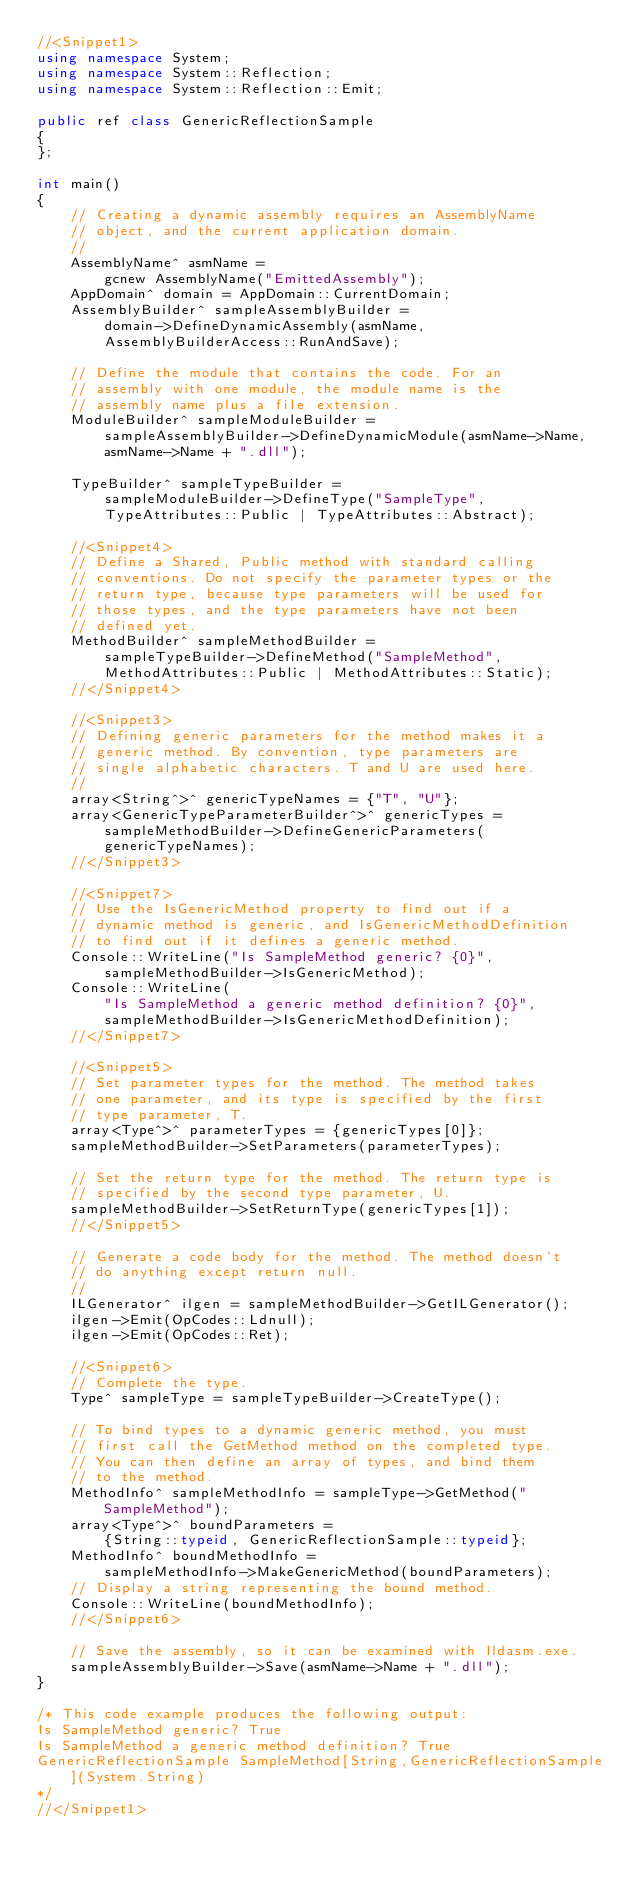<code> <loc_0><loc_0><loc_500><loc_500><_C++_>//<Snippet1>
using namespace System;
using namespace System::Reflection;
using namespace System::Reflection::Emit;

public ref class GenericReflectionSample
{
};

int main()
{
    // Creating a dynamic assembly requires an AssemblyName
    // object, and the current application domain.
    //
    AssemblyName^ asmName =
        gcnew AssemblyName("EmittedAssembly");
    AppDomain^ domain = AppDomain::CurrentDomain;
    AssemblyBuilder^ sampleAssemblyBuilder =
        domain->DefineDynamicAssembly(asmName,
        AssemblyBuilderAccess::RunAndSave);

    // Define the module that contains the code. For an
    // assembly with one module, the module name is the
    // assembly name plus a file extension.
    ModuleBuilder^ sampleModuleBuilder =
        sampleAssemblyBuilder->DefineDynamicModule(asmName->Name,
        asmName->Name + ".dll");

    TypeBuilder^ sampleTypeBuilder =
        sampleModuleBuilder->DefineType("SampleType",
        TypeAttributes::Public | TypeAttributes::Abstract);

    //<Snippet4>
    // Define a Shared, Public method with standard calling
    // conventions. Do not specify the parameter types or the
    // return type, because type parameters will be used for
    // those types, and the type parameters have not been
    // defined yet.
    MethodBuilder^ sampleMethodBuilder =
        sampleTypeBuilder->DefineMethod("SampleMethod",
        MethodAttributes::Public | MethodAttributes::Static);
    //</Snippet4>

    //<Snippet3>
    // Defining generic parameters for the method makes it a
    // generic method. By convention, type parameters are
    // single alphabetic characters. T and U are used here.
    //
    array<String^>^ genericTypeNames = {"T", "U"};
    array<GenericTypeParameterBuilder^>^ genericTypes =
        sampleMethodBuilder->DefineGenericParameters(
        genericTypeNames);
    //</Snippet3>

    //<Snippet7>
    // Use the IsGenericMethod property to find out if a
    // dynamic method is generic, and IsGenericMethodDefinition
    // to find out if it defines a generic method.
    Console::WriteLine("Is SampleMethod generic? {0}",
        sampleMethodBuilder->IsGenericMethod);
    Console::WriteLine(
        "Is SampleMethod a generic method definition? {0}",
        sampleMethodBuilder->IsGenericMethodDefinition);
    //</Snippet7>

    //<Snippet5>
    // Set parameter types for the method. The method takes
    // one parameter, and its type is specified by the first
    // type parameter, T.
    array<Type^>^ parameterTypes = {genericTypes[0]};
    sampleMethodBuilder->SetParameters(parameterTypes);

    // Set the return type for the method. The return type is
    // specified by the second type parameter, U.
    sampleMethodBuilder->SetReturnType(genericTypes[1]);
    //</Snippet5>

    // Generate a code body for the method. The method doesn't
    // do anything except return null.
    //
    ILGenerator^ ilgen = sampleMethodBuilder->GetILGenerator();
    ilgen->Emit(OpCodes::Ldnull);
    ilgen->Emit(OpCodes::Ret);

    //<Snippet6>
    // Complete the type.
    Type^ sampleType = sampleTypeBuilder->CreateType();

    // To bind types to a dynamic generic method, you must
    // first call the GetMethod method on the completed type.
    // You can then define an array of types, and bind them
    // to the method.
    MethodInfo^ sampleMethodInfo = sampleType->GetMethod("SampleMethod");
    array<Type^>^ boundParameters =
        {String::typeid, GenericReflectionSample::typeid};
    MethodInfo^ boundMethodInfo =
        sampleMethodInfo->MakeGenericMethod(boundParameters);
    // Display a string representing the bound method.
    Console::WriteLine(boundMethodInfo);
    //</Snippet6>

    // Save the assembly, so it can be examined with Ildasm.exe.
    sampleAssemblyBuilder->Save(asmName->Name + ".dll");
}

/* This code example produces the following output:
Is SampleMethod generic? True
Is SampleMethod a generic method definition? True
GenericReflectionSample SampleMethod[String,GenericReflectionSample](System.String)
*/
//</Snippet1>



</code> 